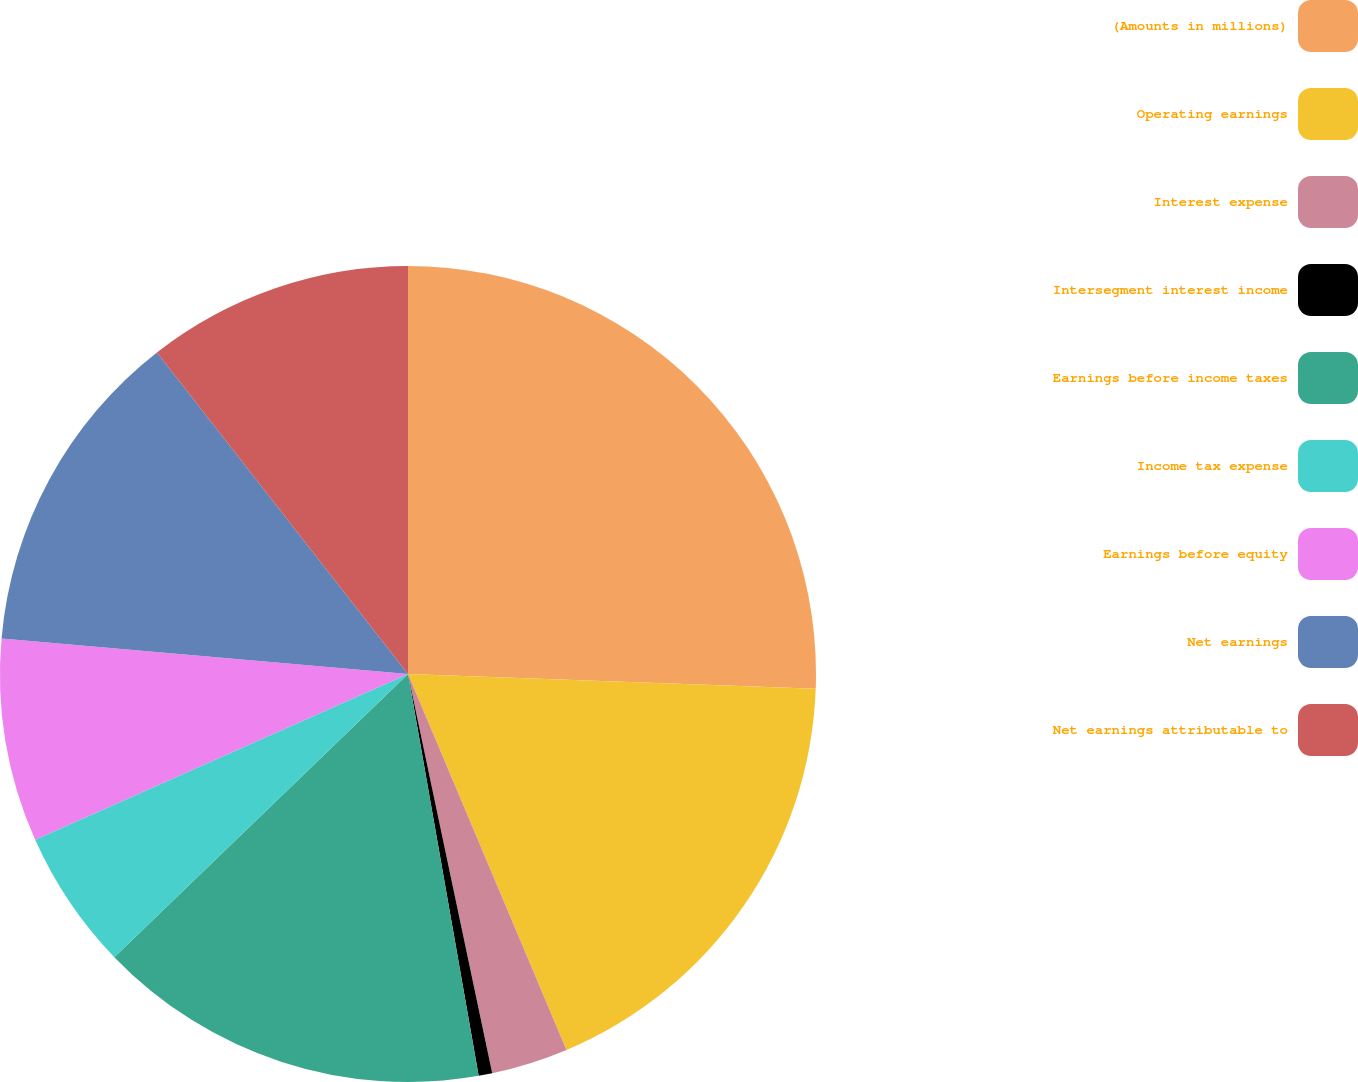Convert chart to OTSL. <chart><loc_0><loc_0><loc_500><loc_500><pie_chart><fcel>(Amounts in millions)<fcel>Operating earnings<fcel>Interest expense<fcel>Intersegment interest income<fcel>Earnings before income taxes<fcel>Income tax expense<fcel>Earnings before equity<fcel>Net earnings<fcel>Net earnings attributable to<nl><fcel>25.58%<fcel>18.07%<fcel>3.04%<fcel>0.54%<fcel>15.56%<fcel>5.55%<fcel>8.05%<fcel>13.06%<fcel>10.55%<nl></chart> 